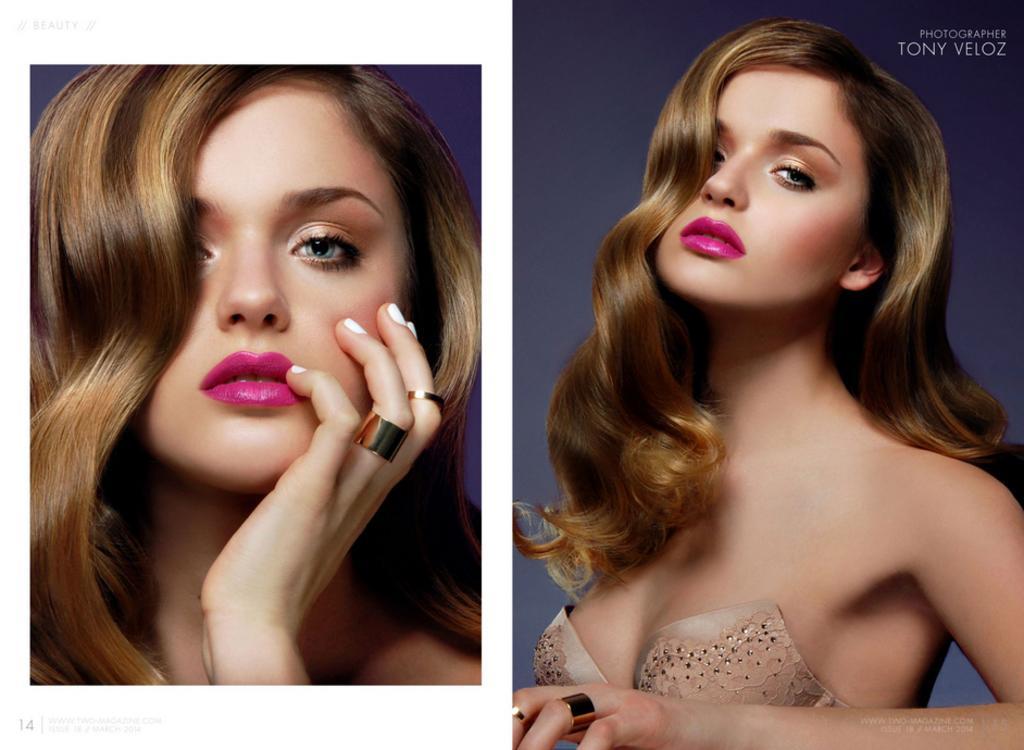Can you describe this image briefly? This picture is a collage of two images. In these two images I can observe a woman. In the top right side I can observe text. 